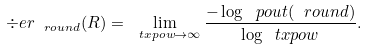Convert formula to latex. <formula><loc_0><loc_0><loc_500><loc_500>\div e r _ { \ r o u n d } ( R ) = \lim _ { \ t x p o w \to \infty } \frac { - \log \ p o u t ( \ r o u n d ) } { \log \ t x p o w } .</formula> 